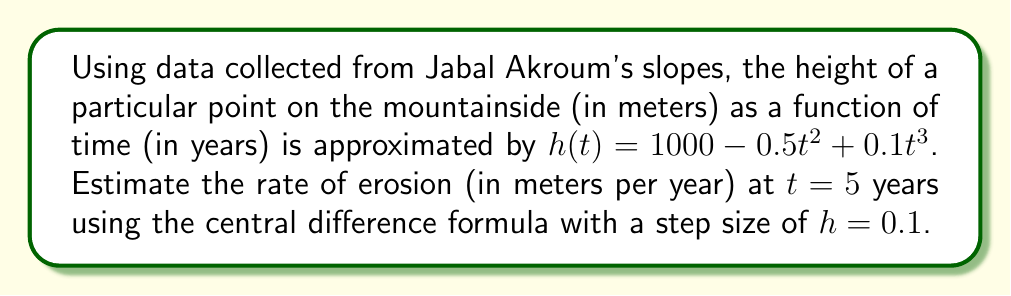Can you solve this math problem? To estimate the rate of erosion, we need to calculate the derivative of the height function at $t = 5$ using the central difference formula.

The central difference formula for the first derivative is:

$$f'(x) \approx \frac{f(x+h) - f(x-h)}{2h}$$

Where $h$ is the step size, and in this case, $h = 0.1$.

Steps:
1) Calculate $h(5+0.1)$ and $h(5-0.1)$:

   $h(5.1) = 1000 - 0.5(5.1)^2 + 0.1(5.1)^3$
   $h(5.1) = 1000 - 13.005 + 13.311 = 1000.306$

   $h(4.9) = 1000 - 0.5(4.9)^2 + 0.1(4.9)^3$
   $h(4.9) = 1000 - 12.005 + 11.725 = 999.720$

2) Apply the central difference formula:

   $$h'(5) \approx \frac{h(5.1) - h(4.9)}{2(0.1)}$$
   $$h'(5) \approx \frac{1000.306 - 999.720}{0.2}$$
   $$h'(5) \approx \frac{0.586}{0.2} = 2.93$$

3) The negative of this value gives the rate of erosion:

   Rate of erosion $\approx -2.93$ meters per year
Answer: $-2.93$ m/year 